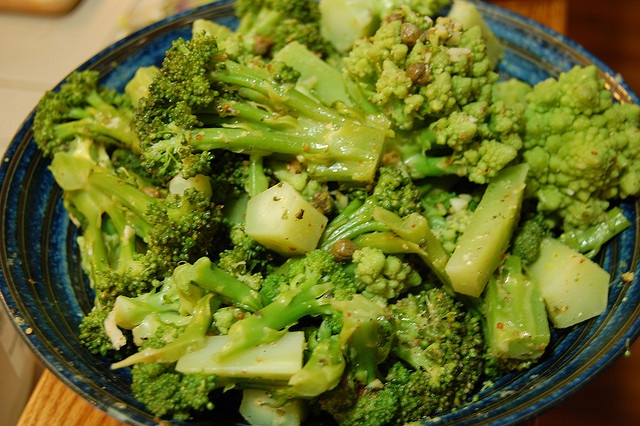Describe the objects in this image and their specific colors. I can see bowl in olive, black, orange, and khaki tones, broccoli in orange, olive, black, and khaki tones, broccoli in orange, olive, and black tones, and broccoli in orange, olive, and black tones in this image. 